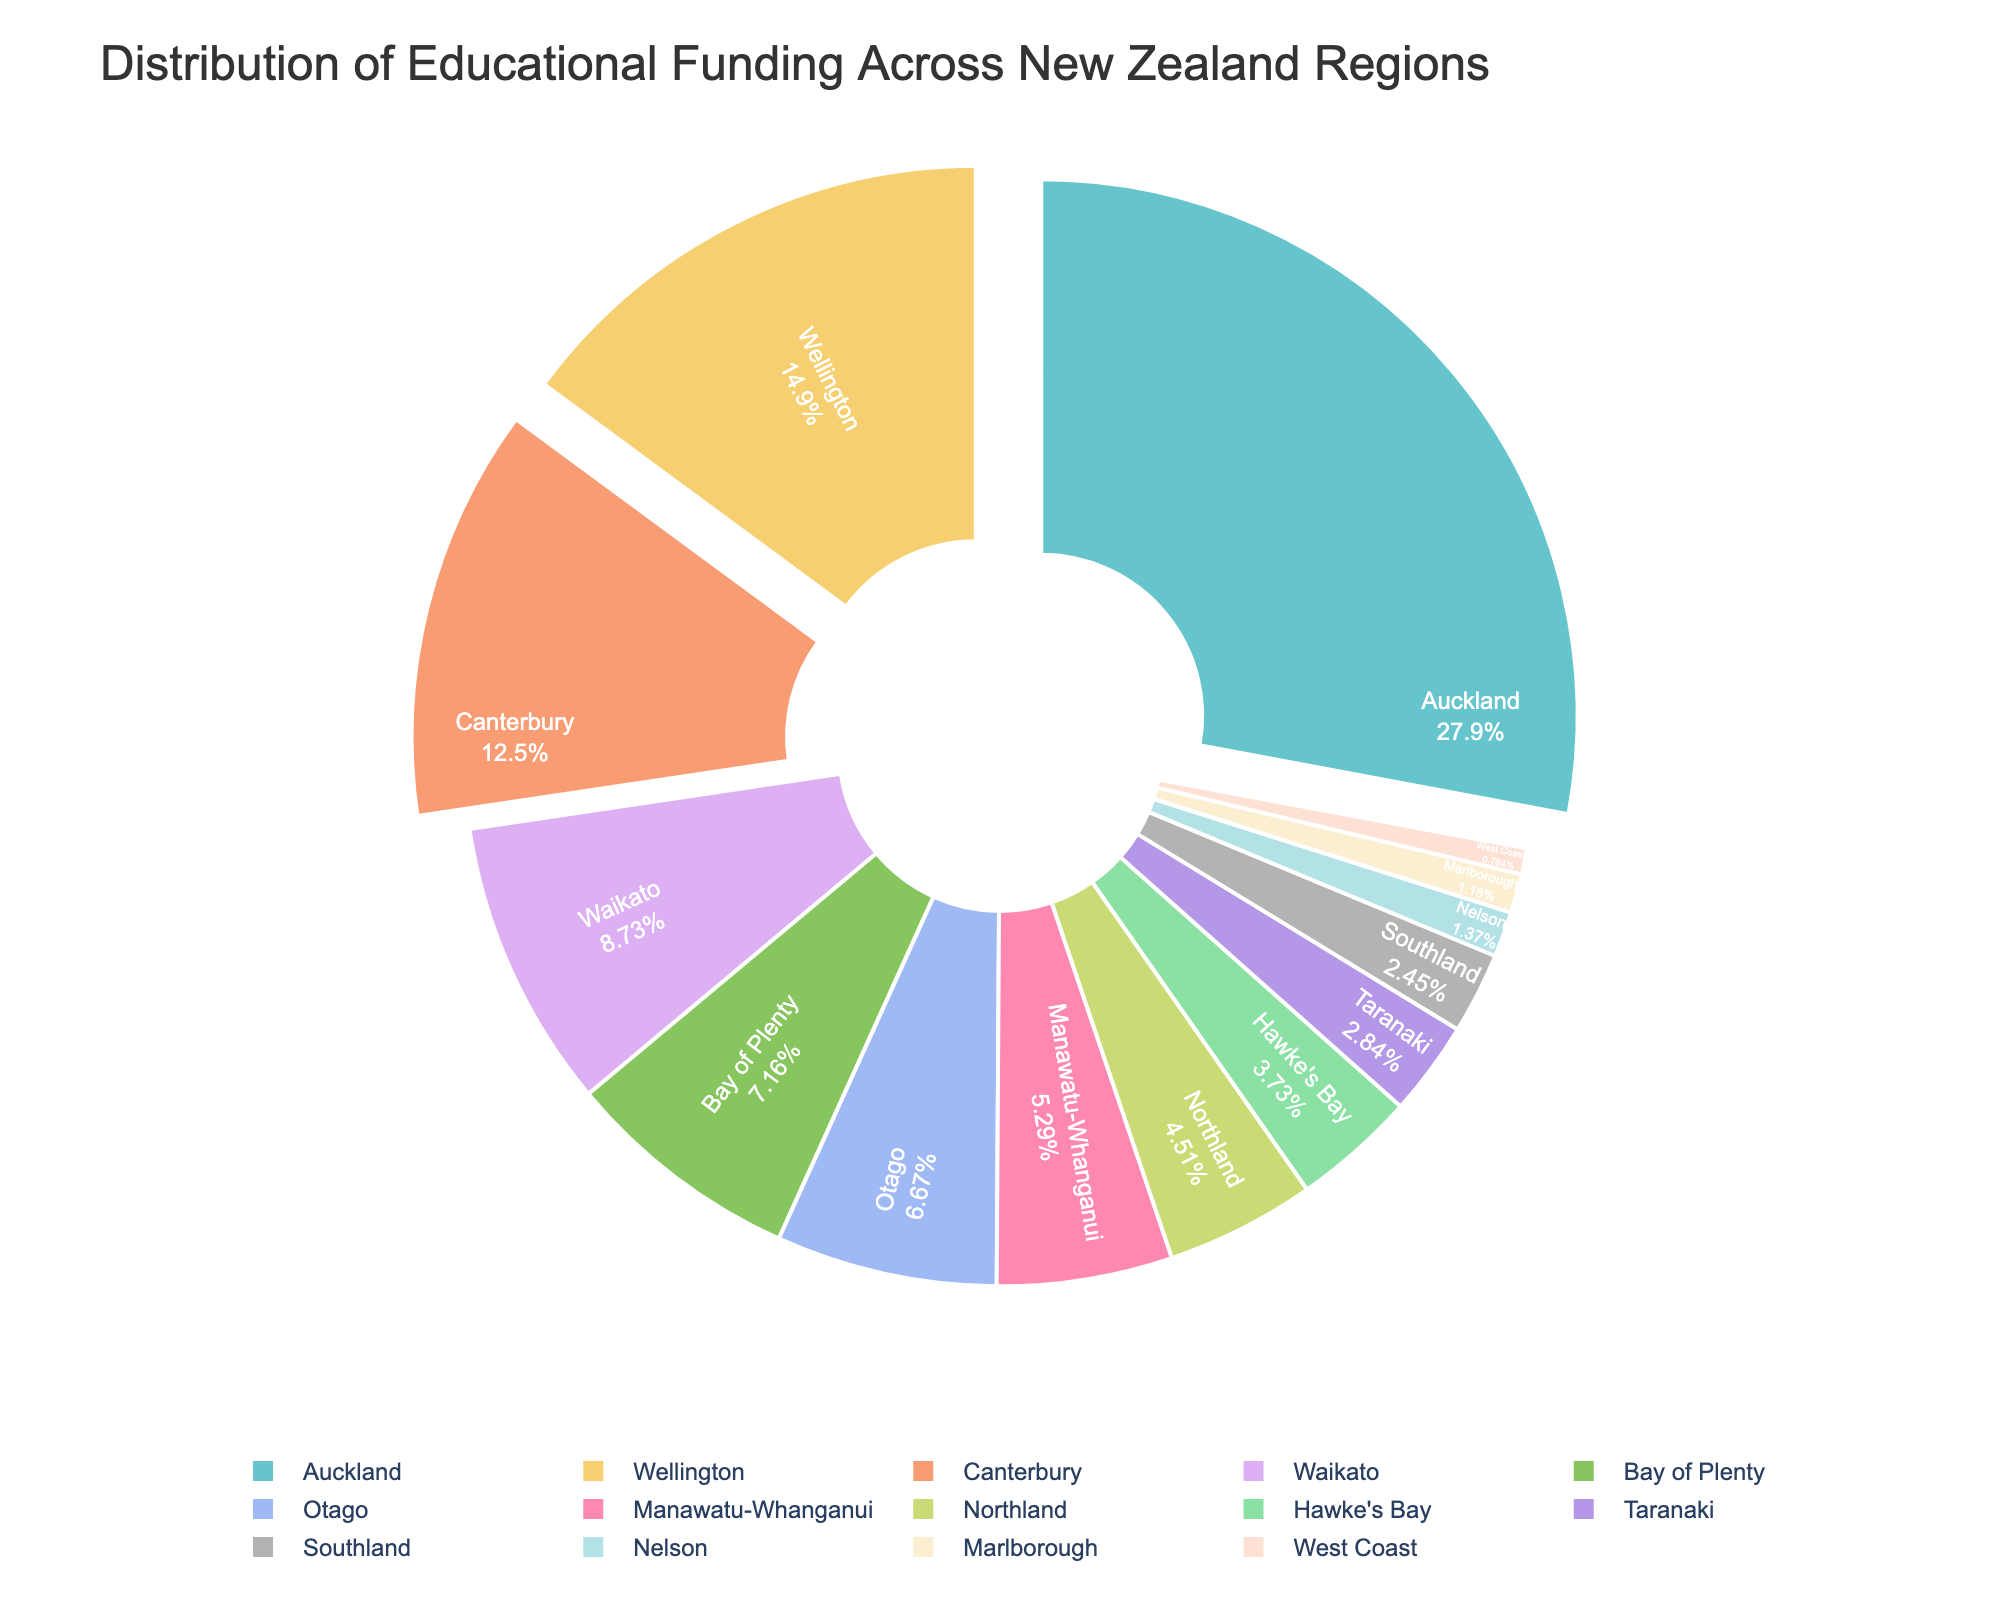Which region receives the highest percentage of educational funding? To determine which region receives the highest percentage, look for the largest segment in the pie chart. Auckland's segment is the largest.
Answer: Auckland Which three regions receive the smallest percentages of educational funding collectively? Identify the regions with the smallest segments: West Coast, Marlborough, and Nelson. Sum their percentages: 0.8% + 1.2% + 1.4% = 3.4%.
Answer: West Coast, Marlborough, Nelson Which region gets more educational funding, Wellington or Canterbury? Compare the sizes of the segments for Wellington and Canterbury. Wellington's segment is larger (15.2% vs. 12.7%).
Answer: Wellington How much more funding percentage does Auckland receive compared to Otago? Determine the difference in funding percentages: Auckland (28.5%) - Otago (6.8%) = 21.7%.
Answer: 21.7% Which region receives nearly double the funding percentage of Northland? Identify Northland's funding percentage (4.6%) and find a region close to double this percentage: Waikato (8.9%) is close to twice 4.6%.
Answer: Waikato What is the combined funding percentage of Bay of Plenty and Taranaki? Sum their percentages: Bay of Plenty (7.3%) + Taranaki (2.9%) = 10.2%.
Answer: 10.2% Which regions receive more than 10% of the total educational funding each? Identify segments with percentages greater than 10%: Auckland (28.5%), Wellington (15.2%), Canterbury (12.7%).
Answer: Auckland, Wellington, Canterbury How does the funding percentage of Hawke's Bay compare to that of Southland? Compare the segments for Hawke's Bay (3.8%) and Southland (2.5%). Hawke's Bay receives more funding.
Answer: Hawke's Bay What is the average funding percentage of Wellington, Canterbury, and Waikato? Sum their percentages and divide by three: (15.2% + 12.7% + 8.9%) / 3 = 12.27%.
Answer: 12.27% Which region's funding percentage is closest to the average funding percentage of all regions? Calculate the average by summing all percentages and dividing by the number of regions: (28.5 + 15.2 + 12.7 + 8.9 + 7.3 + 6.8 + 5.4 + 4.6 + 3.8 + 2.9 + 2.5 + 1.4 + 1.2 + 0.8) / 14 ≈ 8.1%. Bay of Plenty is closest with 7.3%.
Answer: Bay of Plenty 